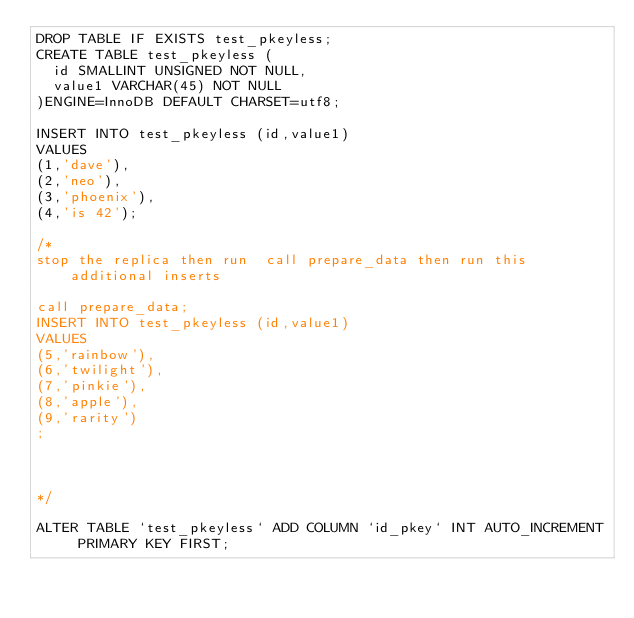<code> <loc_0><loc_0><loc_500><loc_500><_SQL_>DROP TABLE IF EXISTS test_pkeyless;
CREATE TABLE test_pkeyless (
  id SMALLINT UNSIGNED NOT NULL,
  value1 VARCHAR(45) NOT NULL
)ENGINE=InnoDB DEFAULT CHARSET=utf8;

INSERT INTO test_pkeyless (id,value1)
VALUES
(1,'dave'),
(2,'neo'),
(3,'phoenix'),
(4,'is 42');

/*
stop the replica then run  call prepare_data then run this additional inserts 

call prepare_data;
INSERT INTO test_pkeyless (id,value1)
VALUES
(5,'rainbow'),
(6,'twilight'),
(7,'pinkie'),
(8,'apple'),
(9,'rarity')
;



*/

ALTER TABLE `test_pkeyless` ADD COLUMN `id_pkey` INT AUTO_INCREMENT PRIMARY KEY FIRST; 
</code> 